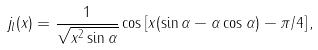Convert formula to latex. <formula><loc_0><loc_0><loc_500><loc_500>j _ { l } ( x ) = \frac { 1 } { \sqrt { x ^ { 2 } \sin \alpha } } \cos \left [ x ( \sin \alpha - \alpha \cos \alpha ) - \pi / 4 \right ] ,</formula> 